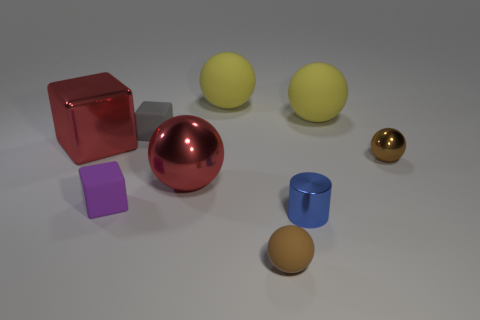What can you infer about the lighting in this scene based on the shadows of the objects? The shadows of the objects are soft and diffused, indicating that the lighting in this scene is not very harsh and possibly coming from an overhead diffuse light source, giving the scene a calm and neutral atmosphere. 